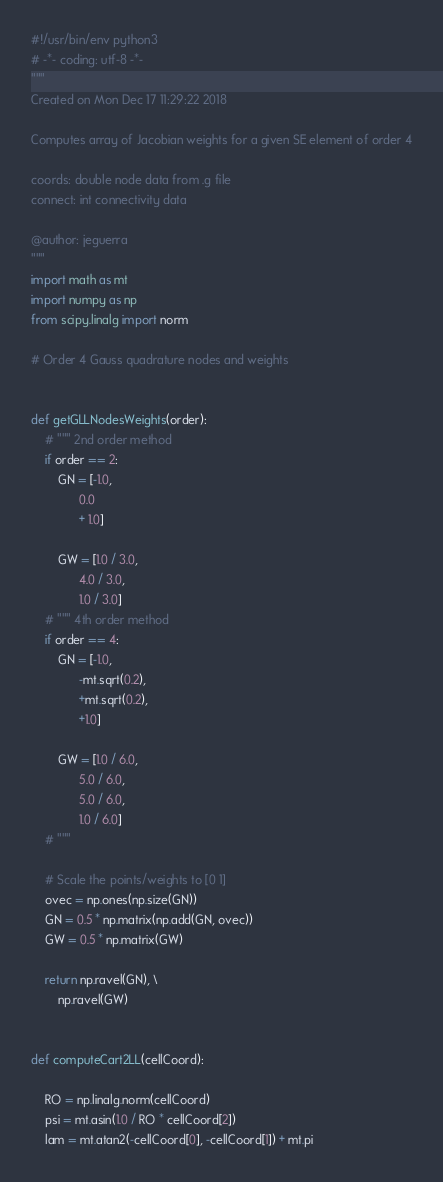<code> <loc_0><loc_0><loc_500><loc_500><_Python_>#!/usr/bin/env python3
# -*- coding: utf-8 -*-
"""
Created on Mon Dec 17 11:29:22 2018

Computes array of Jacobian weights for a given SE element of order 4

coords: double node data from .g file
connect: int connectivity data

@author: jeguerra
"""
import math as mt
import numpy as np
from scipy.linalg import norm

# Order 4 Gauss quadrature nodes and weights


def getGLLNodesWeights(order):
    # """ 2nd order method
    if order == 2:
        GN = [-1.0,
              0.0
              + 1.0]

        GW = [1.0 / 3.0,
              4.0 / 3.0,
              1.0 / 3.0]
    # """ 4th order method
    if order == 4:
        GN = [-1.0,
              -mt.sqrt(0.2),
              +mt.sqrt(0.2),
              +1.0]

        GW = [1.0 / 6.0,
              5.0 / 6.0,
              5.0 / 6.0,
              1.0 / 6.0]
    # """

    # Scale the points/weights to [0 1]
    ovec = np.ones(np.size(GN))
    GN = 0.5 * np.matrix(np.add(GN, ovec))
    GW = 0.5 * np.matrix(GW)

    return np.ravel(GN), \
        np.ravel(GW)


def computeCart2LL(cellCoord):

    RO = np.linalg.norm(cellCoord)
    psi = mt.asin(1.0 / RO * cellCoord[2])
    lam = mt.atan2(-cellCoord[0], -cellCoord[1]) + mt.pi</code> 